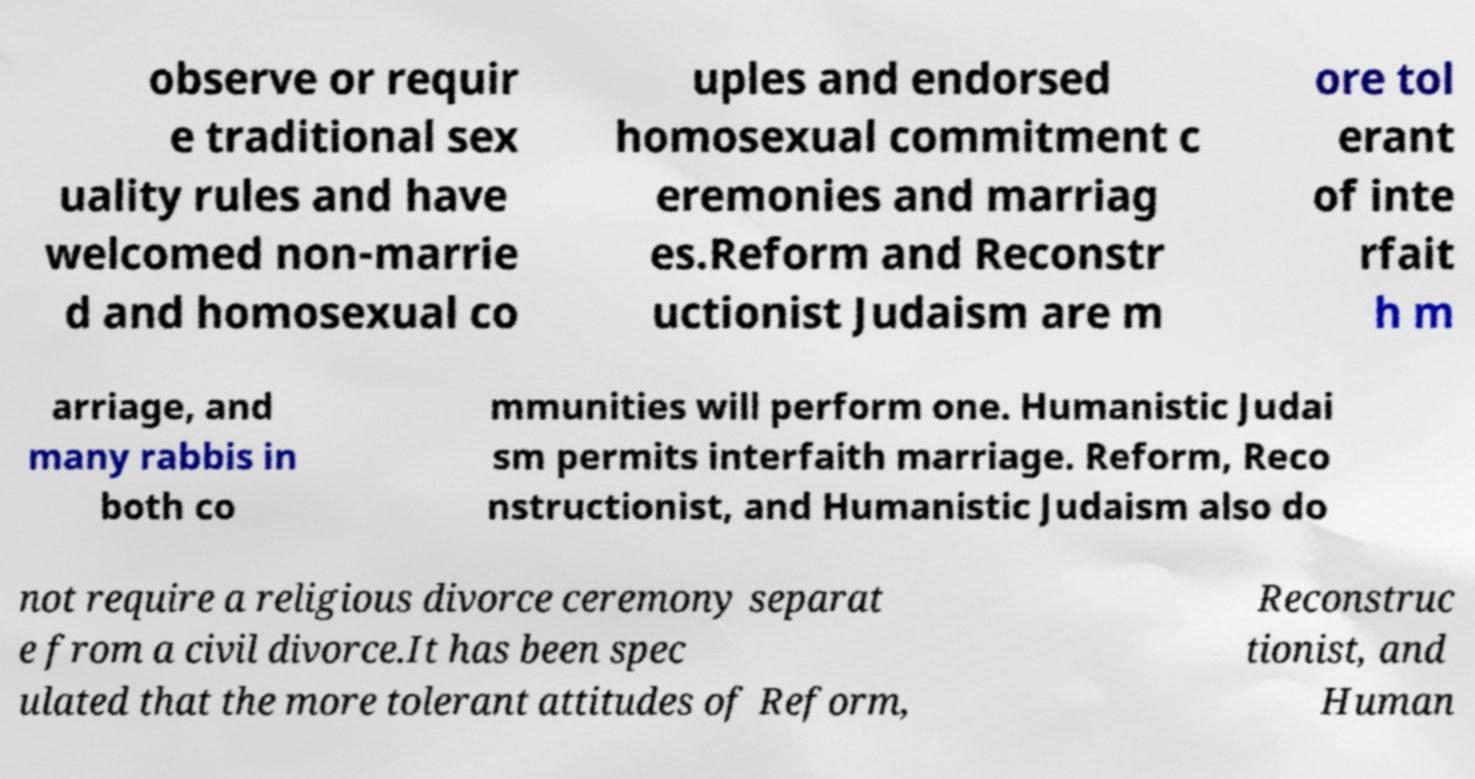Please identify and transcribe the text found in this image. observe or requir e traditional sex uality rules and have welcomed non-marrie d and homosexual co uples and endorsed homosexual commitment c eremonies and marriag es.Reform and Reconstr uctionist Judaism are m ore tol erant of inte rfait h m arriage, and many rabbis in both co mmunities will perform one. Humanistic Judai sm permits interfaith marriage. Reform, Reco nstructionist, and Humanistic Judaism also do not require a religious divorce ceremony separat e from a civil divorce.It has been spec ulated that the more tolerant attitudes of Reform, Reconstruc tionist, and Human 